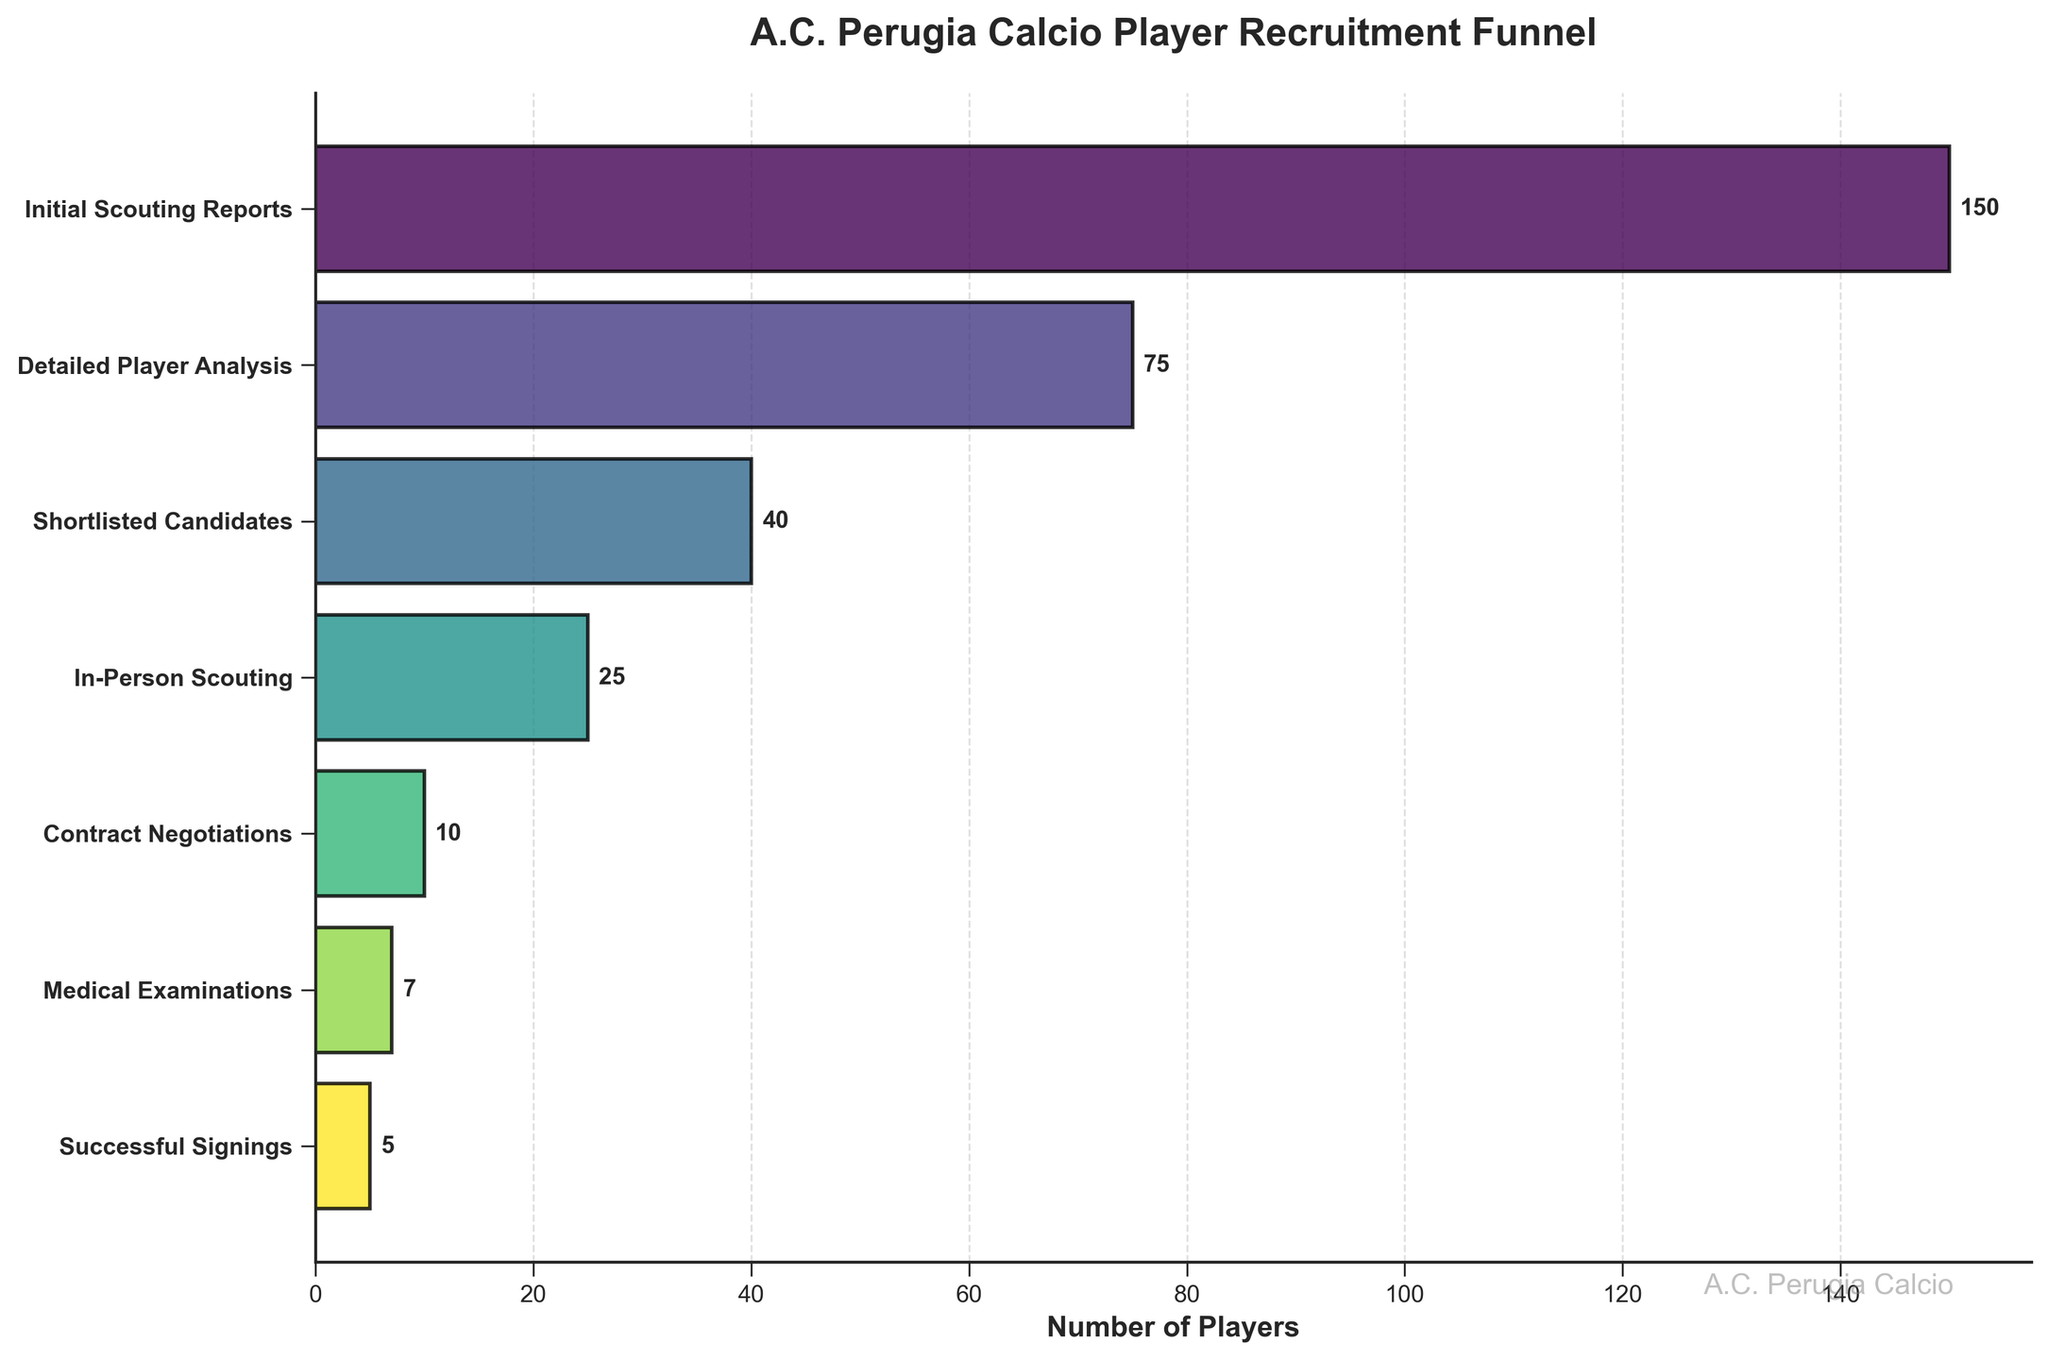What is the title of the funnel chart? The title of the funnel chart is usually found at the top. In this chart, it reads "A.C. Perugia Calcio Player Recruitment Funnel".
Answer: A.C. Perugia Calcio Player Recruitment Funnel How many players successfully signed with the team? The number of players successfully signed is shown at the bottom of the funnel in the stage "Successful Signings". It is labeled with a value of 5.
Answer: 5 Which stage comes right before "Contract Negotiations"? By looking at the sequential order of the stages, the stage right before "Contract Negotiations" is "In-Person Scouting".
Answer: In-Person Scouting What is the total number of players evaluated during "Detailed Player Analysis" and "Shortlisted Candidates"? The number of players evaluated in "Detailed Player Analysis" is 75 and in "Shortlisted Candidates" it is 40. Adding them together: 75 + 40 = 115.
Answer: 115 How many stages does the player recruitment process have? There are 7 stages in the player recruitment process, as shown by the number of distinct labels on the y-axis.
Answer: 7 What is the difference in the number of players between "Initial Scouting Reports" and "Medical Examinations"? "Initial Scouting Reports" has 150 players and "Medical Examinations" has 7 players. The difference: 150 - 7 = 143.
Answer: 143 Which stage has the highest number of players? The stage with the highest number of players is "Initial Scouting Reports" with 150 players, which is the widest bar in the chart.
Answer: Initial Scouting Reports How many players are excluded between "Shortlisted Candidates" and "In-Person Scouting"? The number of players in "Shortlisted Candidates" is 40 and in "In-Person Scouting" it is 25. The difference: 40 - 25 = 15.
Answer: 15 Which stages involve fewer than 10 players each? The stages involving fewer than 10 players are "Contract Negotiations" with 10, "Medical Examinations" with 7, and "Successful Signings" with 5.
Answer: Medical Examinations, Successful Signings What percentage of the players evaluated in "Initial Scouting Reports" eventually end up in "Contract Negotiations"? "Initial Scouting Reports" has 150 players and "Contract Negotiations" involves 10 players. The percentage: (10/150) * 100 = 6.67%.
Answer: 6.67% 